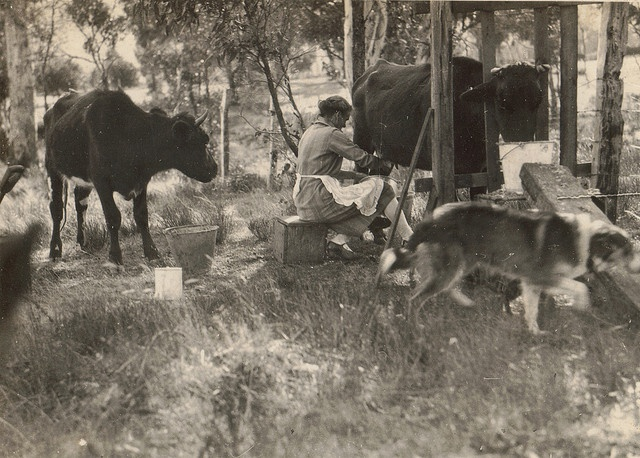Describe the objects in this image and their specific colors. I can see dog in gray, black, and darkgray tones, cow in gray and black tones, cow in gray and black tones, and people in gray, darkgray, and black tones in this image. 